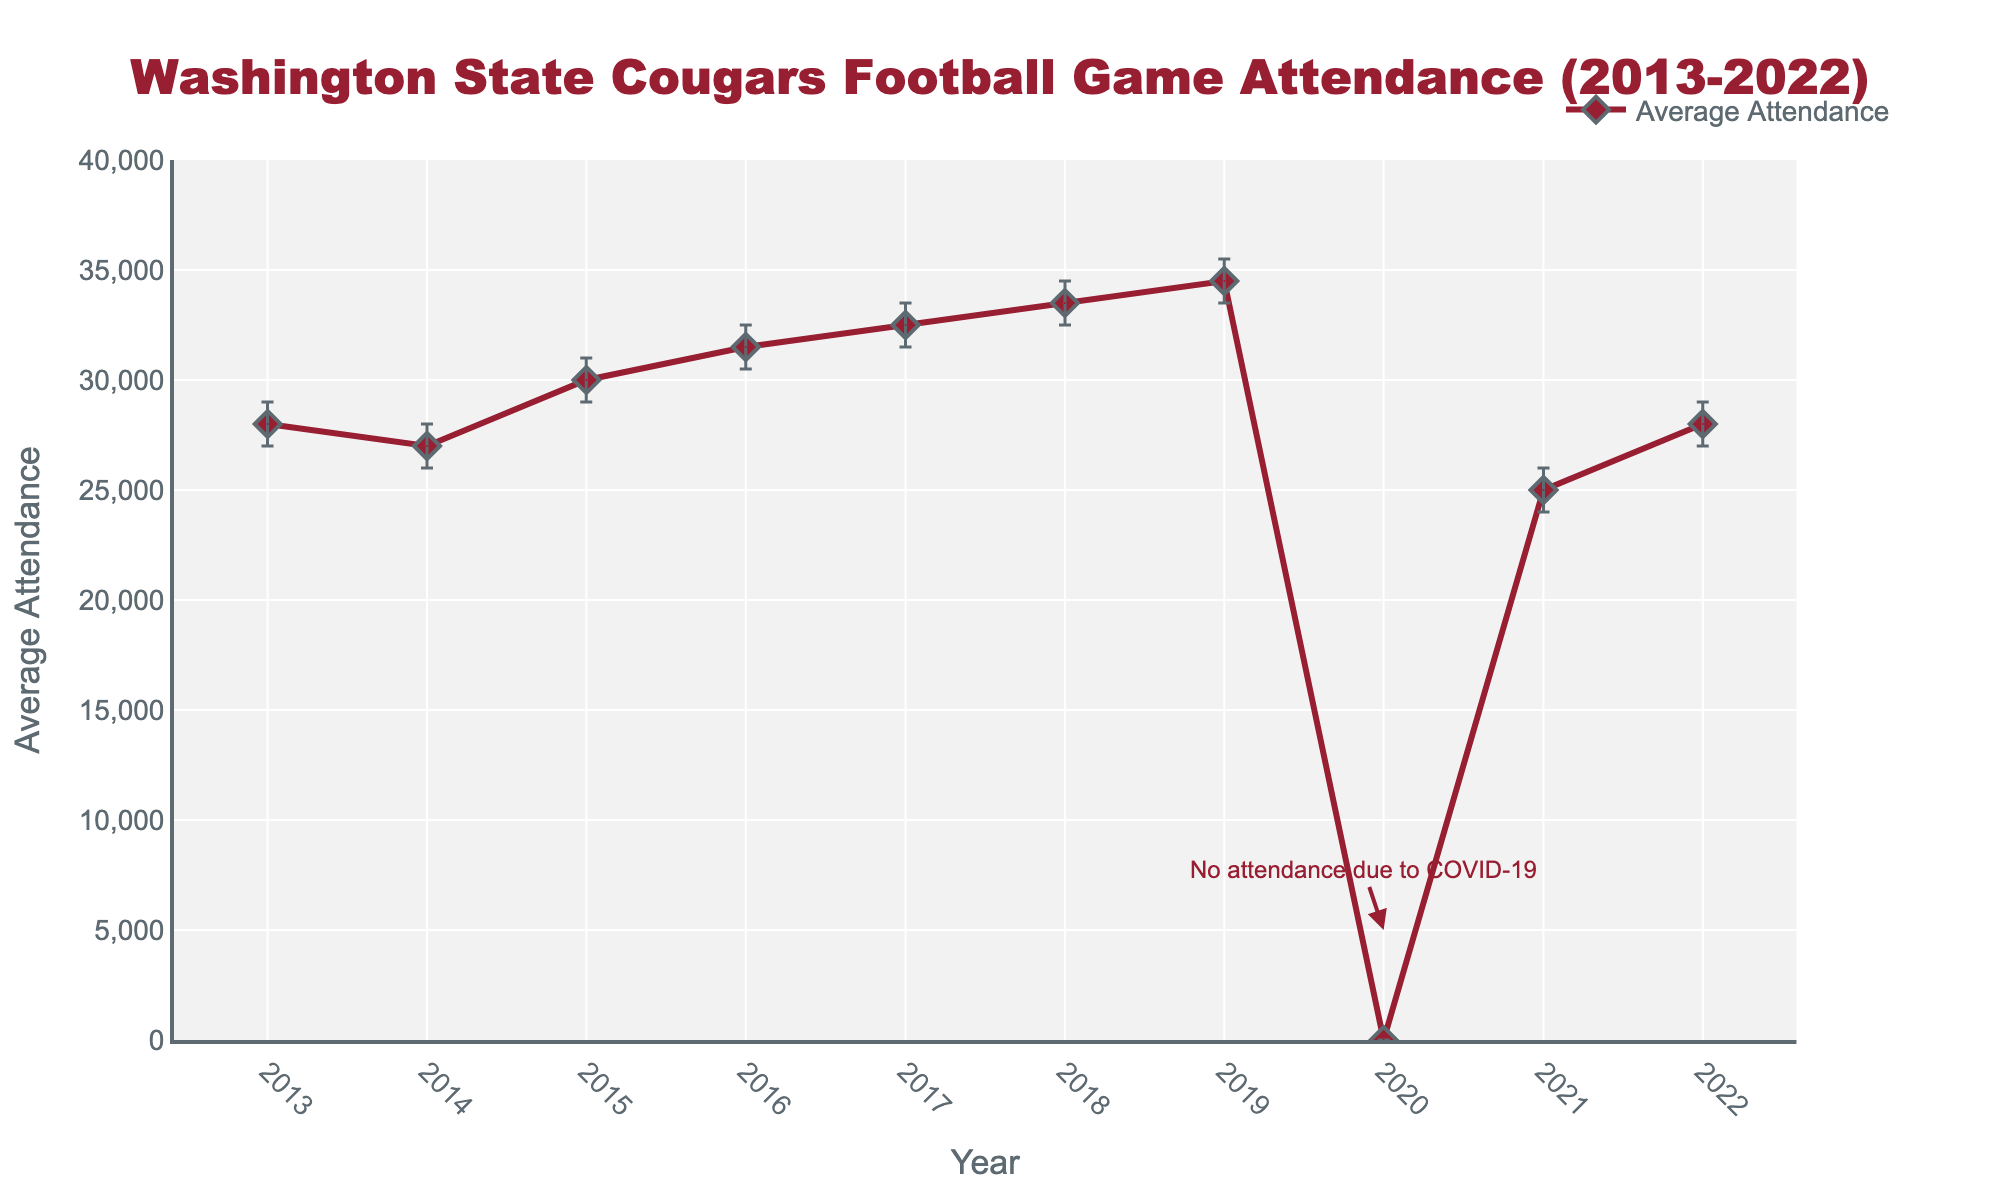What years are shown on the x-axis? The x-axis represents the years from 2013 to 2022 as indicated by the tick marks and labels.
Answer: 2013 to 2022 What is the title of the figure? The title is found at the top of the plot and reads "Washington State Cougars Football Game Attendance (2013-2022)."
Answer: Washington State Cougars Football Game Attendance (2013-2022) How does the average attendance in 2019 compare to that in 2021? From the plot, we can see that the average attendance in 2019 is higher than in 2021. In 2019, it was 34500, while in 2021, it was 25000.
Answer: Higher in 2019 What is the average attendance in 2015? The average attendance for 2015 is shown by the marker and is 30000.
Answer: 30000 Why is there a significant drop in attendance in 2020? An annotation on the plot points out that there was no attendance in 2020 due to COVID-19.
Answer: No attendance due to COVID-19 What is the lowest average attendance after 2020? By examining the plot, the lowest average attendance after 2020 is in 2021, with 25000 attendees.
Answer: 25000 What is the trend in average attendance from 2013 to 2019? The average attendance generally increased from 2013 (28000) to 2019 (34500), which shows an upward trend over this period.
Answer: Upward trend How wide is the confidence interval for average attendance in 2022? To find the width of the confidence interval, subtract the lower confidence interval value from the upper confidence interval for 2022: 29000 - 27000 = 2000.
Answer: 2000 Which year has the highest average attendance? The plot shows the highest average attendance is in 2019, with 34500 attendees.
Answer: 2019 Compare the confidence intervals of 2014 and 2018. The confidence interval for 2014 is between 26000 and 28000, and for 2018, it is between 32500 and 34500. Both intervals span a range of 2000, but 2018 has higher overall attendance figures.
Answer: 2018 has higher overall attendance 